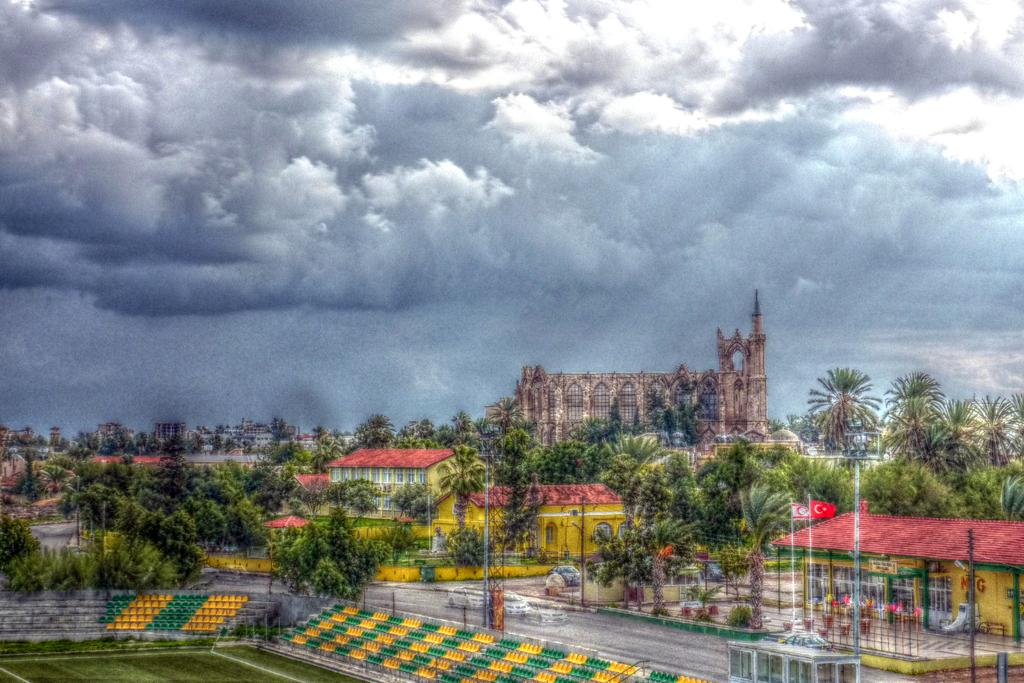What type of structures can be seen in the image? There are houses and buildings in the image. What natural elements are present in the image? There are trees, grass, and plants in the image. What man-made objects can be seen in the image? There are poles, flags, vehicles, a road, chairs, and other objects in the image. What is visible in the background of the image? The sky is visible in the background of the image, with clouds present. Can you tell me how many branches are being gripped in the discussion in the image? There is no discussion or branches present in the image. What type of grip is being used by the plants in the image? The image does not show any plants gripping anything; it only shows plants as stationary objects. 